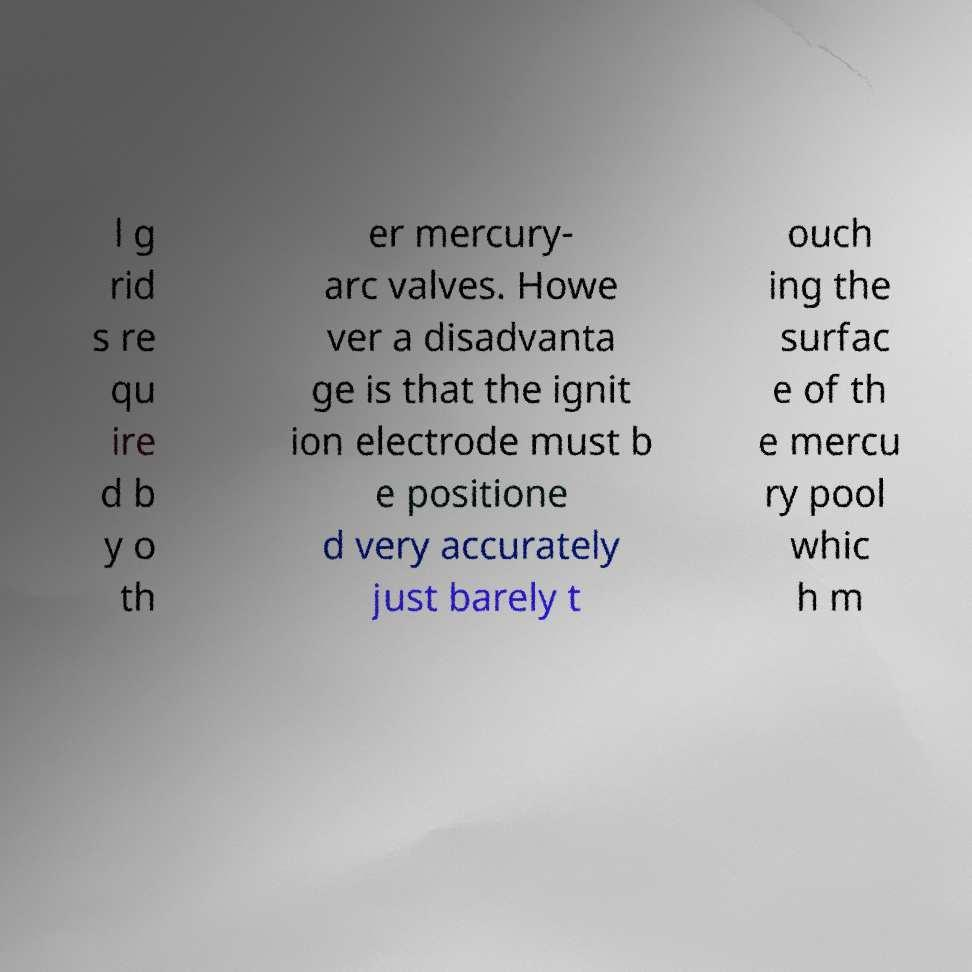Please read and relay the text visible in this image. What does it say? l g rid s re qu ire d b y o th er mercury- arc valves. Howe ver a disadvanta ge is that the ignit ion electrode must b e positione d very accurately just barely t ouch ing the surfac e of th e mercu ry pool whic h m 